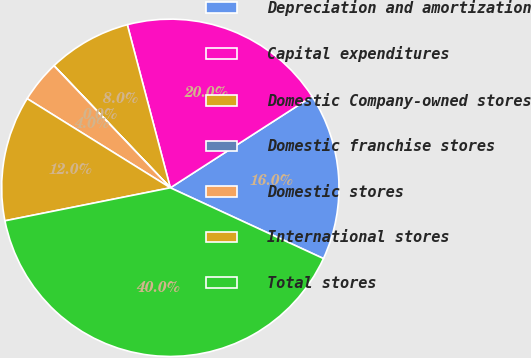Convert chart to OTSL. <chart><loc_0><loc_0><loc_500><loc_500><pie_chart><fcel>Depreciation and amortization<fcel>Capital expenditures<fcel>Domestic Company-owned stores<fcel>Domestic franchise stores<fcel>Domestic stores<fcel>International stores<fcel>Total stores<nl><fcel>16.0%<fcel>19.99%<fcel>8.01%<fcel>0.01%<fcel>4.01%<fcel>12.0%<fcel>39.97%<nl></chart> 